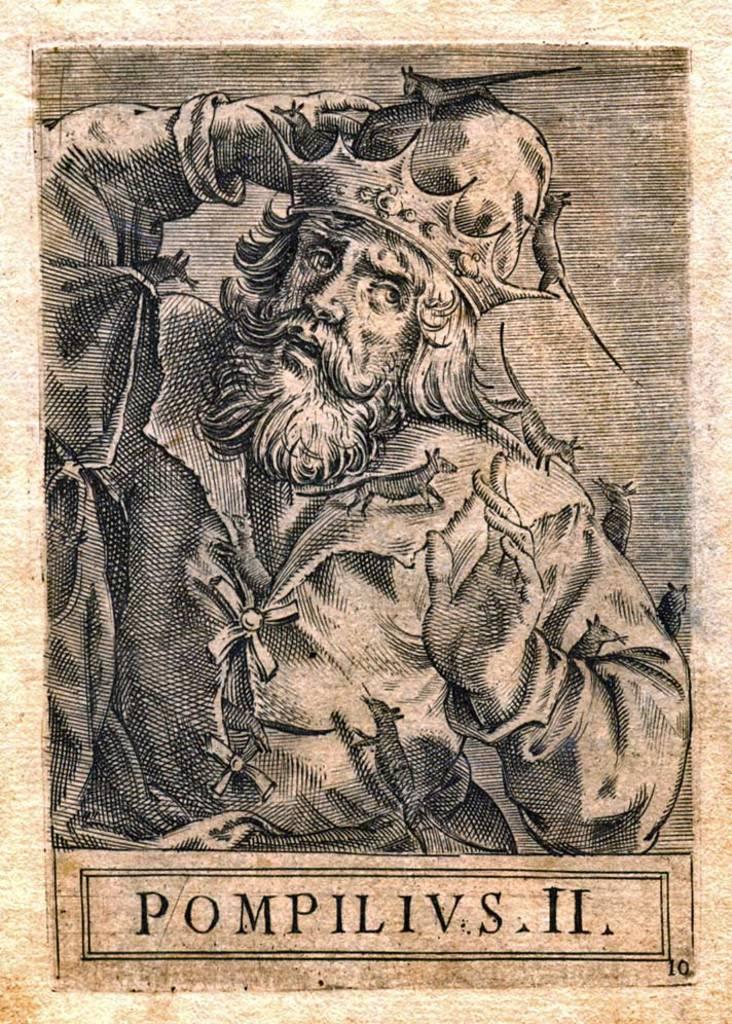What is this a drawing of?
Ensure brevity in your answer.  Pompilivs ii. 